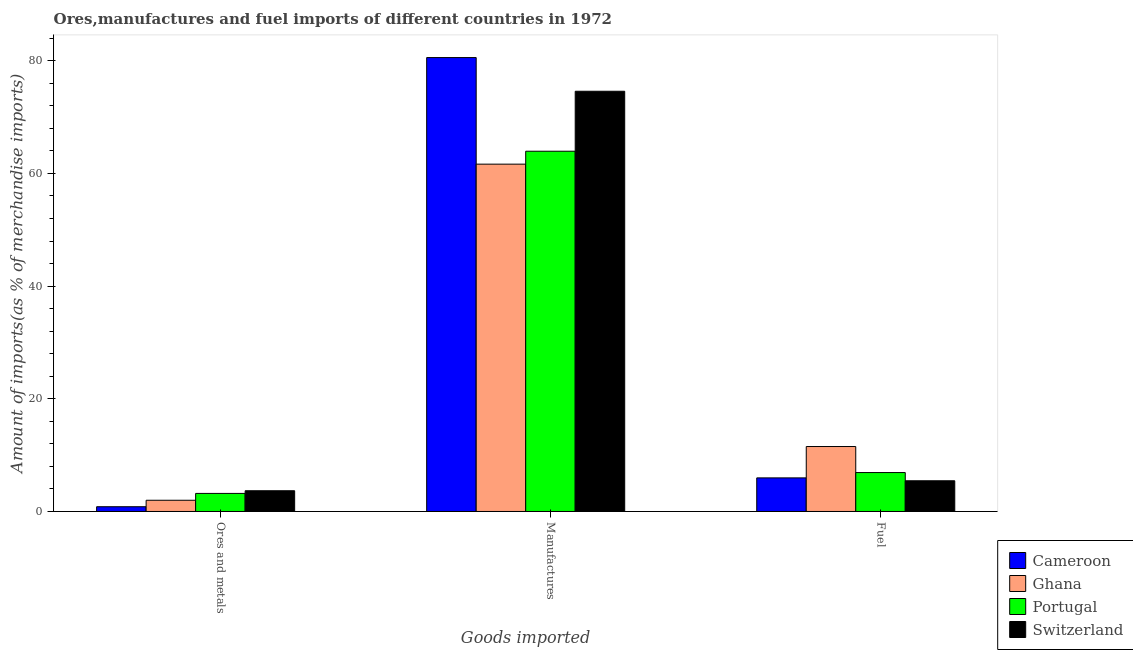Are the number of bars on each tick of the X-axis equal?
Ensure brevity in your answer.  Yes. What is the label of the 3rd group of bars from the left?
Provide a succinct answer. Fuel. What is the percentage of ores and metals imports in Ghana?
Provide a short and direct response. 1.99. Across all countries, what is the maximum percentage of manufactures imports?
Make the answer very short. 80.56. Across all countries, what is the minimum percentage of fuel imports?
Offer a terse response. 5.45. In which country was the percentage of fuel imports maximum?
Your answer should be very brief. Ghana. In which country was the percentage of ores and metals imports minimum?
Provide a short and direct response. Cameroon. What is the total percentage of ores and metals imports in the graph?
Your answer should be compact. 9.72. What is the difference between the percentage of ores and metals imports in Portugal and that in Switzerland?
Provide a succinct answer. -0.47. What is the difference between the percentage of fuel imports in Switzerland and the percentage of manufactures imports in Portugal?
Provide a succinct answer. -58.49. What is the average percentage of fuel imports per country?
Your answer should be compact. 7.46. What is the difference between the percentage of ores and metals imports and percentage of fuel imports in Cameroon?
Give a very brief answer. -5.12. In how many countries, is the percentage of fuel imports greater than 64 %?
Your answer should be compact. 0. What is the ratio of the percentage of fuel imports in Portugal to that in Ghana?
Provide a succinct answer. 0.6. What is the difference between the highest and the second highest percentage of fuel imports?
Your response must be concise. 4.62. What is the difference between the highest and the lowest percentage of manufactures imports?
Offer a terse response. 18.92. Is the sum of the percentage of fuel imports in Portugal and Ghana greater than the maximum percentage of manufactures imports across all countries?
Provide a succinct answer. No. What does the 4th bar from the left in Fuel represents?
Provide a succinct answer. Switzerland. What does the 1st bar from the right in Ores and metals represents?
Keep it short and to the point. Switzerland. Is it the case that in every country, the sum of the percentage of ores and metals imports and percentage of manufactures imports is greater than the percentage of fuel imports?
Your answer should be compact. Yes. Are all the bars in the graph horizontal?
Your answer should be very brief. No. How many countries are there in the graph?
Ensure brevity in your answer.  4. Are the values on the major ticks of Y-axis written in scientific E-notation?
Your answer should be very brief. No. Where does the legend appear in the graph?
Ensure brevity in your answer.  Bottom right. How are the legend labels stacked?
Keep it short and to the point. Vertical. What is the title of the graph?
Your answer should be very brief. Ores,manufactures and fuel imports of different countries in 1972. What is the label or title of the X-axis?
Provide a short and direct response. Goods imported. What is the label or title of the Y-axis?
Your answer should be very brief. Amount of imports(as % of merchandise imports). What is the Amount of imports(as % of merchandise imports) in Cameroon in Ores and metals?
Ensure brevity in your answer.  0.84. What is the Amount of imports(as % of merchandise imports) in Ghana in Ores and metals?
Offer a terse response. 1.99. What is the Amount of imports(as % of merchandise imports) of Portugal in Ores and metals?
Provide a short and direct response. 3.21. What is the Amount of imports(as % of merchandise imports) of Switzerland in Ores and metals?
Your response must be concise. 3.68. What is the Amount of imports(as % of merchandise imports) of Cameroon in Manufactures?
Your answer should be very brief. 80.56. What is the Amount of imports(as % of merchandise imports) in Ghana in Manufactures?
Your response must be concise. 61.65. What is the Amount of imports(as % of merchandise imports) of Portugal in Manufactures?
Your answer should be compact. 63.94. What is the Amount of imports(as % of merchandise imports) in Switzerland in Manufactures?
Offer a very short reply. 74.58. What is the Amount of imports(as % of merchandise imports) in Cameroon in Fuel?
Offer a terse response. 5.96. What is the Amount of imports(as % of merchandise imports) of Ghana in Fuel?
Your response must be concise. 11.53. What is the Amount of imports(as % of merchandise imports) in Portugal in Fuel?
Your answer should be compact. 6.91. What is the Amount of imports(as % of merchandise imports) in Switzerland in Fuel?
Your answer should be very brief. 5.45. Across all Goods imported, what is the maximum Amount of imports(as % of merchandise imports) in Cameroon?
Your answer should be very brief. 80.56. Across all Goods imported, what is the maximum Amount of imports(as % of merchandise imports) in Ghana?
Offer a very short reply. 61.65. Across all Goods imported, what is the maximum Amount of imports(as % of merchandise imports) of Portugal?
Give a very brief answer. 63.94. Across all Goods imported, what is the maximum Amount of imports(as % of merchandise imports) of Switzerland?
Keep it short and to the point. 74.58. Across all Goods imported, what is the minimum Amount of imports(as % of merchandise imports) in Cameroon?
Provide a succinct answer. 0.84. Across all Goods imported, what is the minimum Amount of imports(as % of merchandise imports) of Ghana?
Your response must be concise. 1.99. Across all Goods imported, what is the minimum Amount of imports(as % of merchandise imports) in Portugal?
Give a very brief answer. 3.21. Across all Goods imported, what is the minimum Amount of imports(as % of merchandise imports) of Switzerland?
Your answer should be very brief. 3.68. What is the total Amount of imports(as % of merchandise imports) of Cameroon in the graph?
Make the answer very short. 87.37. What is the total Amount of imports(as % of merchandise imports) of Ghana in the graph?
Your answer should be compact. 75.17. What is the total Amount of imports(as % of merchandise imports) in Portugal in the graph?
Offer a very short reply. 74.06. What is the total Amount of imports(as % of merchandise imports) of Switzerland in the graph?
Ensure brevity in your answer.  83.72. What is the difference between the Amount of imports(as % of merchandise imports) of Cameroon in Ores and metals and that in Manufactures?
Ensure brevity in your answer.  -79.72. What is the difference between the Amount of imports(as % of merchandise imports) of Ghana in Ores and metals and that in Manufactures?
Your answer should be compact. -59.66. What is the difference between the Amount of imports(as % of merchandise imports) in Portugal in Ores and metals and that in Manufactures?
Your answer should be very brief. -60.74. What is the difference between the Amount of imports(as % of merchandise imports) in Switzerland in Ores and metals and that in Manufactures?
Your answer should be very brief. -70.9. What is the difference between the Amount of imports(as % of merchandise imports) in Cameroon in Ores and metals and that in Fuel?
Make the answer very short. -5.12. What is the difference between the Amount of imports(as % of merchandise imports) in Ghana in Ores and metals and that in Fuel?
Offer a terse response. -9.54. What is the difference between the Amount of imports(as % of merchandise imports) in Portugal in Ores and metals and that in Fuel?
Provide a succinct answer. -3.7. What is the difference between the Amount of imports(as % of merchandise imports) of Switzerland in Ores and metals and that in Fuel?
Offer a terse response. -1.77. What is the difference between the Amount of imports(as % of merchandise imports) in Cameroon in Manufactures and that in Fuel?
Offer a very short reply. 74.6. What is the difference between the Amount of imports(as % of merchandise imports) in Ghana in Manufactures and that in Fuel?
Ensure brevity in your answer.  50.12. What is the difference between the Amount of imports(as % of merchandise imports) of Portugal in Manufactures and that in Fuel?
Provide a short and direct response. 57.03. What is the difference between the Amount of imports(as % of merchandise imports) in Switzerland in Manufactures and that in Fuel?
Make the answer very short. 69.13. What is the difference between the Amount of imports(as % of merchandise imports) of Cameroon in Ores and metals and the Amount of imports(as % of merchandise imports) of Ghana in Manufactures?
Offer a terse response. -60.81. What is the difference between the Amount of imports(as % of merchandise imports) in Cameroon in Ores and metals and the Amount of imports(as % of merchandise imports) in Portugal in Manufactures?
Keep it short and to the point. -63.1. What is the difference between the Amount of imports(as % of merchandise imports) of Cameroon in Ores and metals and the Amount of imports(as % of merchandise imports) of Switzerland in Manufactures?
Keep it short and to the point. -73.74. What is the difference between the Amount of imports(as % of merchandise imports) of Ghana in Ores and metals and the Amount of imports(as % of merchandise imports) of Portugal in Manufactures?
Keep it short and to the point. -61.95. What is the difference between the Amount of imports(as % of merchandise imports) of Ghana in Ores and metals and the Amount of imports(as % of merchandise imports) of Switzerland in Manufactures?
Offer a terse response. -72.59. What is the difference between the Amount of imports(as % of merchandise imports) of Portugal in Ores and metals and the Amount of imports(as % of merchandise imports) of Switzerland in Manufactures?
Provide a succinct answer. -71.38. What is the difference between the Amount of imports(as % of merchandise imports) of Cameroon in Ores and metals and the Amount of imports(as % of merchandise imports) of Ghana in Fuel?
Give a very brief answer. -10.69. What is the difference between the Amount of imports(as % of merchandise imports) in Cameroon in Ores and metals and the Amount of imports(as % of merchandise imports) in Portugal in Fuel?
Keep it short and to the point. -6.07. What is the difference between the Amount of imports(as % of merchandise imports) of Cameroon in Ores and metals and the Amount of imports(as % of merchandise imports) of Switzerland in Fuel?
Keep it short and to the point. -4.61. What is the difference between the Amount of imports(as % of merchandise imports) of Ghana in Ores and metals and the Amount of imports(as % of merchandise imports) of Portugal in Fuel?
Offer a terse response. -4.92. What is the difference between the Amount of imports(as % of merchandise imports) of Ghana in Ores and metals and the Amount of imports(as % of merchandise imports) of Switzerland in Fuel?
Ensure brevity in your answer.  -3.46. What is the difference between the Amount of imports(as % of merchandise imports) of Portugal in Ores and metals and the Amount of imports(as % of merchandise imports) of Switzerland in Fuel?
Make the answer very short. -2.25. What is the difference between the Amount of imports(as % of merchandise imports) of Cameroon in Manufactures and the Amount of imports(as % of merchandise imports) of Ghana in Fuel?
Offer a terse response. 69.03. What is the difference between the Amount of imports(as % of merchandise imports) in Cameroon in Manufactures and the Amount of imports(as % of merchandise imports) in Portugal in Fuel?
Make the answer very short. 73.66. What is the difference between the Amount of imports(as % of merchandise imports) of Cameroon in Manufactures and the Amount of imports(as % of merchandise imports) of Switzerland in Fuel?
Make the answer very short. 75.11. What is the difference between the Amount of imports(as % of merchandise imports) in Ghana in Manufactures and the Amount of imports(as % of merchandise imports) in Portugal in Fuel?
Your response must be concise. 54.74. What is the difference between the Amount of imports(as % of merchandise imports) of Ghana in Manufactures and the Amount of imports(as % of merchandise imports) of Switzerland in Fuel?
Offer a very short reply. 56.2. What is the difference between the Amount of imports(as % of merchandise imports) of Portugal in Manufactures and the Amount of imports(as % of merchandise imports) of Switzerland in Fuel?
Keep it short and to the point. 58.49. What is the average Amount of imports(as % of merchandise imports) of Cameroon per Goods imported?
Your response must be concise. 29.12. What is the average Amount of imports(as % of merchandise imports) in Ghana per Goods imported?
Offer a very short reply. 25.06. What is the average Amount of imports(as % of merchandise imports) of Portugal per Goods imported?
Your answer should be very brief. 24.69. What is the average Amount of imports(as % of merchandise imports) of Switzerland per Goods imported?
Provide a succinct answer. 27.91. What is the difference between the Amount of imports(as % of merchandise imports) in Cameroon and Amount of imports(as % of merchandise imports) in Ghana in Ores and metals?
Your answer should be very brief. -1.15. What is the difference between the Amount of imports(as % of merchandise imports) in Cameroon and Amount of imports(as % of merchandise imports) in Portugal in Ores and metals?
Offer a very short reply. -2.36. What is the difference between the Amount of imports(as % of merchandise imports) in Cameroon and Amount of imports(as % of merchandise imports) in Switzerland in Ores and metals?
Make the answer very short. -2.84. What is the difference between the Amount of imports(as % of merchandise imports) of Ghana and Amount of imports(as % of merchandise imports) of Portugal in Ores and metals?
Provide a succinct answer. -1.21. What is the difference between the Amount of imports(as % of merchandise imports) of Ghana and Amount of imports(as % of merchandise imports) of Switzerland in Ores and metals?
Your answer should be compact. -1.69. What is the difference between the Amount of imports(as % of merchandise imports) of Portugal and Amount of imports(as % of merchandise imports) of Switzerland in Ores and metals?
Your response must be concise. -0.47. What is the difference between the Amount of imports(as % of merchandise imports) of Cameroon and Amount of imports(as % of merchandise imports) of Ghana in Manufactures?
Ensure brevity in your answer.  18.92. What is the difference between the Amount of imports(as % of merchandise imports) of Cameroon and Amount of imports(as % of merchandise imports) of Portugal in Manufactures?
Provide a succinct answer. 16.62. What is the difference between the Amount of imports(as % of merchandise imports) of Cameroon and Amount of imports(as % of merchandise imports) of Switzerland in Manufactures?
Make the answer very short. 5.98. What is the difference between the Amount of imports(as % of merchandise imports) in Ghana and Amount of imports(as % of merchandise imports) in Portugal in Manufactures?
Offer a very short reply. -2.29. What is the difference between the Amount of imports(as % of merchandise imports) in Ghana and Amount of imports(as % of merchandise imports) in Switzerland in Manufactures?
Your response must be concise. -12.94. What is the difference between the Amount of imports(as % of merchandise imports) in Portugal and Amount of imports(as % of merchandise imports) in Switzerland in Manufactures?
Your answer should be compact. -10.64. What is the difference between the Amount of imports(as % of merchandise imports) of Cameroon and Amount of imports(as % of merchandise imports) of Ghana in Fuel?
Offer a terse response. -5.57. What is the difference between the Amount of imports(as % of merchandise imports) of Cameroon and Amount of imports(as % of merchandise imports) of Portugal in Fuel?
Give a very brief answer. -0.95. What is the difference between the Amount of imports(as % of merchandise imports) of Cameroon and Amount of imports(as % of merchandise imports) of Switzerland in Fuel?
Provide a succinct answer. 0.51. What is the difference between the Amount of imports(as % of merchandise imports) of Ghana and Amount of imports(as % of merchandise imports) of Portugal in Fuel?
Ensure brevity in your answer.  4.62. What is the difference between the Amount of imports(as % of merchandise imports) of Ghana and Amount of imports(as % of merchandise imports) of Switzerland in Fuel?
Keep it short and to the point. 6.08. What is the difference between the Amount of imports(as % of merchandise imports) in Portugal and Amount of imports(as % of merchandise imports) in Switzerland in Fuel?
Make the answer very short. 1.46. What is the ratio of the Amount of imports(as % of merchandise imports) of Cameroon in Ores and metals to that in Manufactures?
Your answer should be compact. 0.01. What is the ratio of the Amount of imports(as % of merchandise imports) in Ghana in Ores and metals to that in Manufactures?
Give a very brief answer. 0.03. What is the ratio of the Amount of imports(as % of merchandise imports) in Portugal in Ores and metals to that in Manufactures?
Give a very brief answer. 0.05. What is the ratio of the Amount of imports(as % of merchandise imports) of Switzerland in Ores and metals to that in Manufactures?
Provide a short and direct response. 0.05. What is the ratio of the Amount of imports(as % of merchandise imports) of Cameroon in Ores and metals to that in Fuel?
Provide a short and direct response. 0.14. What is the ratio of the Amount of imports(as % of merchandise imports) of Ghana in Ores and metals to that in Fuel?
Keep it short and to the point. 0.17. What is the ratio of the Amount of imports(as % of merchandise imports) of Portugal in Ores and metals to that in Fuel?
Give a very brief answer. 0.46. What is the ratio of the Amount of imports(as % of merchandise imports) in Switzerland in Ores and metals to that in Fuel?
Your answer should be very brief. 0.68. What is the ratio of the Amount of imports(as % of merchandise imports) in Cameroon in Manufactures to that in Fuel?
Provide a succinct answer. 13.51. What is the ratio of the Amount of imports(as % of merchandise imports) in Ghana in Manufactures to that in Fuel?
Provide a succinct answer. 5.35. What is the ratio of the Amount of imports(as % of merchandise imports) of Portugal in Manufactures to that in Fuel?
Your response must be concise. 9.25. What is the ratio of the Amount of imports(as % of merchandise imports) in Switzerland in Manufactures to that in Fuel?
Your answer should be very brief. 13.68. What is the difference between the highest and the second highest Amount of imports(as % of merchandise imports) of Cameroon?
Give a very brief answer. 74.6. What is the difference between the highest and the second highest Amount of imports(as % of merchandise imports) in Ghana?
Your answer should be very brief. 50.12. What is the difference between the highest and the second highest Amount of imports(as % of merchandise imports) in Portugal?
Offer a very short reply. 57.03. What is the difference between the highest and the second highest Amount of imports(as % of merchandise imports) in Switzerland?
Make the answer very short. 69.13. What is the difference between the highest and the lowest Amount of imports(as % of merchandise imports) in Cameroon?
Your response must be concise. 79.72. What is the difference between the highest and the lowest Amount of imports(as % of merchandise imports) in Ghana?
Provide a succinct answer. 59.66. What is the difference between the highest and the lowest Amount of imports(as % of merchandise imports) of Portugal?
Ensure brevity in your answer.  60.74. What is the difference between the highest and the lowest Amount of imports(as % of merchandise imports) in Switzerland?
Make the answer very short. 70.9. 